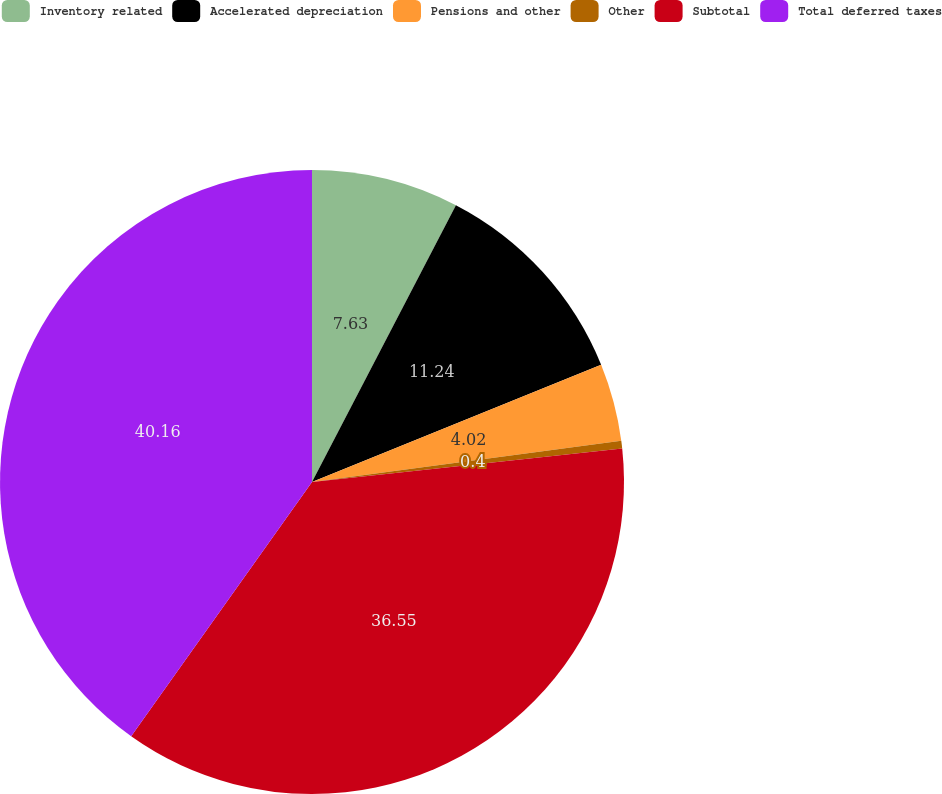Convert chart to OTSL. <chart><loc_0><loc_0><loc_500><loc_500><pie_chart><fcel>Inventory related<fcel>Accelerated depreciation<fcel>Pensions and other<fcel>Other<fcel>Subtotal<fcel>Total deferred taxes<nl><fcel>7.63%<fcel>11.24%<fcel>4.02%<fcel>0.4%<fcel>36.55%<fcel>40.16%<nl></chart> 